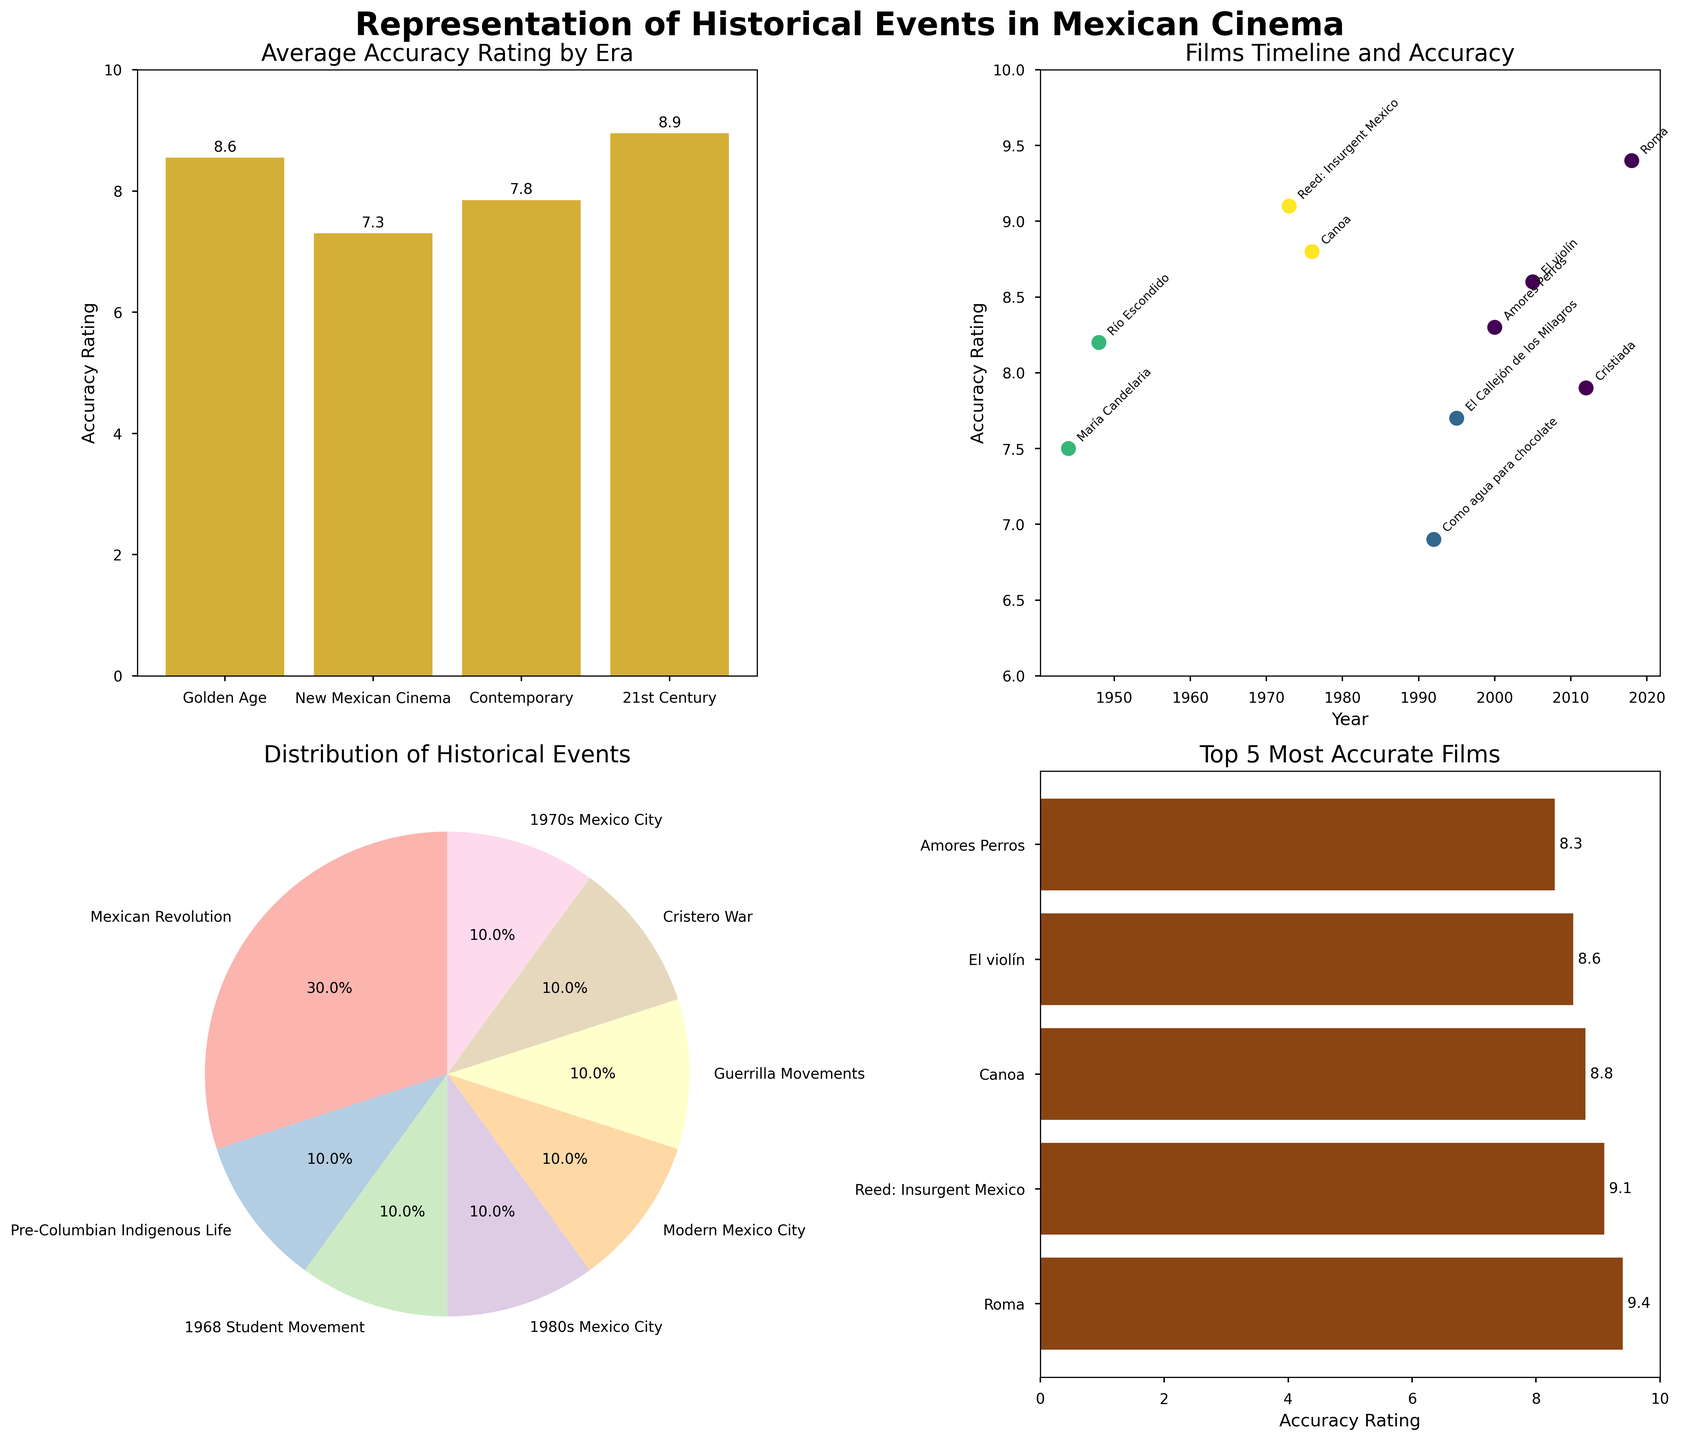What is the title of the overall figure? The title is located at the top of the figure, specifying what the entire plot is about. It reads "Representation of Historical Events in Mexican Cinema."
Answer: Representation of Historical Events in Mexican Cinema How many eras are represented in the Average Accuracy Rating by Era subplot? In the Average Accuracy Rating by Era subplot, there are bars representing each era. Counting these bars will give the number of eras.
Answer: Four Which era has the highest average accuracy rating? In the Average Accuracy Rating by Era subplot, compare the heights of the bars across different eras. The highest bar represents the era with the highest average accuracy rating.
Answer: 21st Century What is the accuracy rating of the movie "Río Escondido"? In the Films Timeline and Accuracy subplot, locate "Río Escondido" along the x-axis by its year, 1948, and check its corresponding y-axis value for accuracy rating.
Answer: 8.2 How many films have an accuracy rating above 8.0? In the Films Timeline and Accuracy subplot, count the number of data points that fall above the y-axis value of 8.0.
Answer: Seven Which historical event is most frequently represented in the films? The Distribution of Historical Events subplot shows a pie chart with different historical events. Identify the event with the largest segment.
Answer: Mexican Revolution What is the lowest accuracy rating among the top 5 most accurate films? In the Top 5 Most Accurate Films subplot, check the bar with the lowest accuracy rating value among the displayed films.
Answer: 8.6 Which film in the Contemporary era has the highest accuracy rating, and what is that rating? In the Films Timeline and Accuracy subplot, focus on points categorized in the Contemporary era. Identify the highest y-value among these points, representing the highest accuracy rating.
Answer: El Callejón de los Milagros, 7.7 Compare the average accuracy rating of Golden Age and New Mexican Cinema. Which is higher and by how much? In the Average Accuracy Rating by Era subplot, compare the bars representing Golden Age and New Mexican Cinema. Subtract the lower value from the higher value to find the difference.
Answer: New Mexican Cinema by 1.3 Which film from the 21st Century era has the highest accuracy rating? In the Films Timeline and Accuracy subplot, look for the highest y-value among points categorized in the 21st Century era.
Answer: Roma 